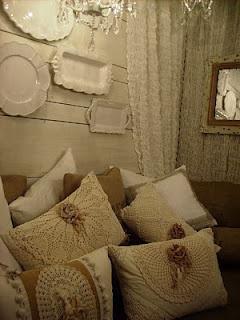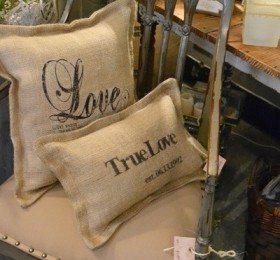The first image is the image on the left, the second image is the image on the right. Considering the images on both sides, is "An image shows pillows on a bed with a deep brown headboard." valid? Answer yes or no. No. 